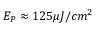Convert formula to latex. <formula><loc_0><loc_0><loc_500><loc_500>E _ { P } \approx 1 2 5 \mu J / c m ^ { 2 }</formula> 